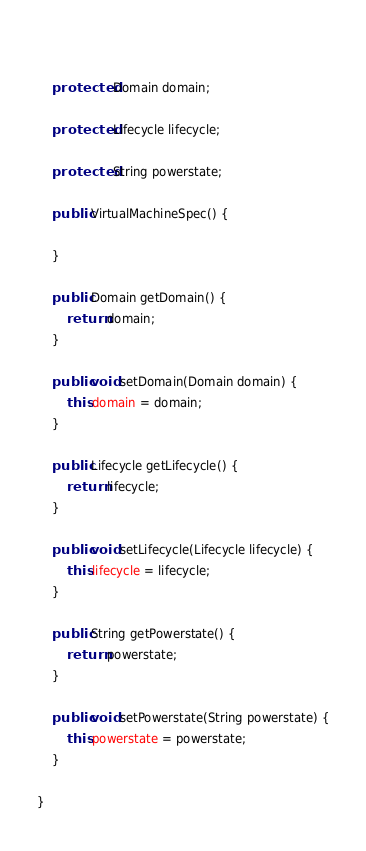Convert code to text. <code><loc_0><loc_0><loc_500><loc_500><_Java_>	

	protected Domain domain;

	protected Lifecycle lifecycle;
	
	protected String powerstate;
	
	public VirtualMachineSpec() {

	}

	public Domain getDomain() {
		return domain;
	}

	public void setDomain(Domain domain) {
		this.domain = domain;
	}

	public Lifecycle getLifecycle() {
		return lifecycle;
	}

	public void setLifecycle(Lifecycle lifecycle) {
		this.lifecycle = lifecycle;
	}

	public String getPowerstate() {
		return powerstate;
	}

	public void setPowerstate(String powerstate) {
		this.powerstate = powerstate;
	}
	
}
</code> 